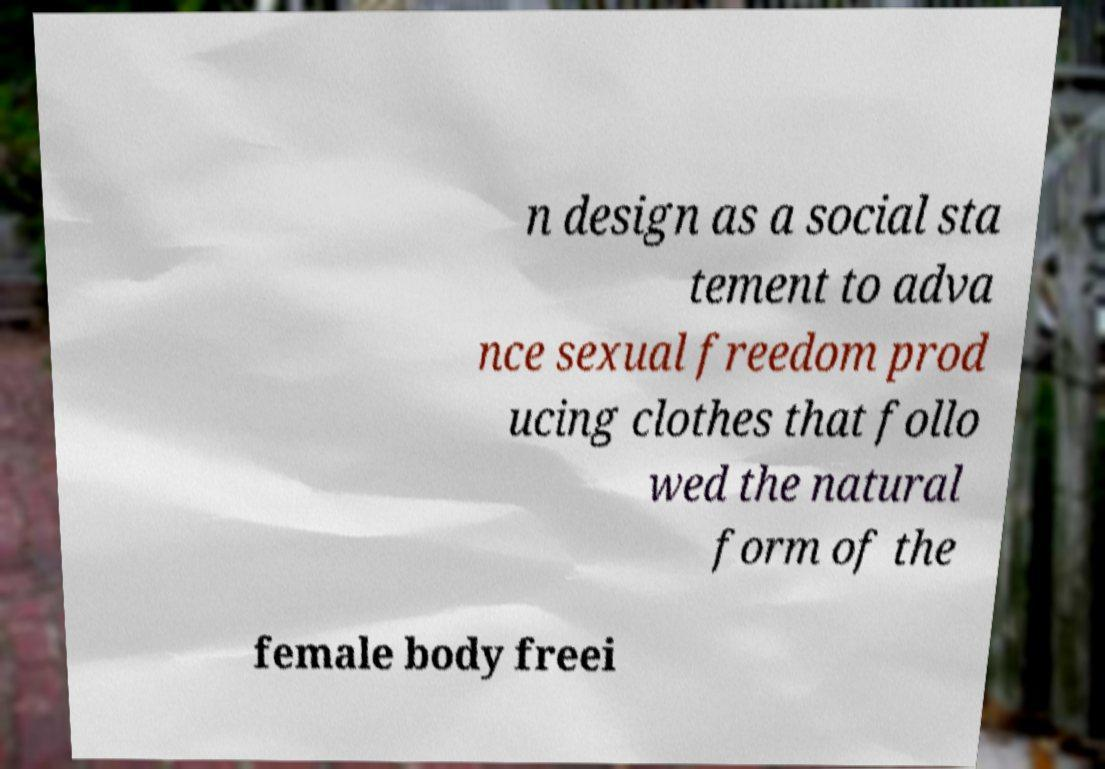Could you extract and type out the text from this image? n design as a social sta tement to adva nce sexual freedom prod ucing clothes that follo wed the natural form of the female body freei 